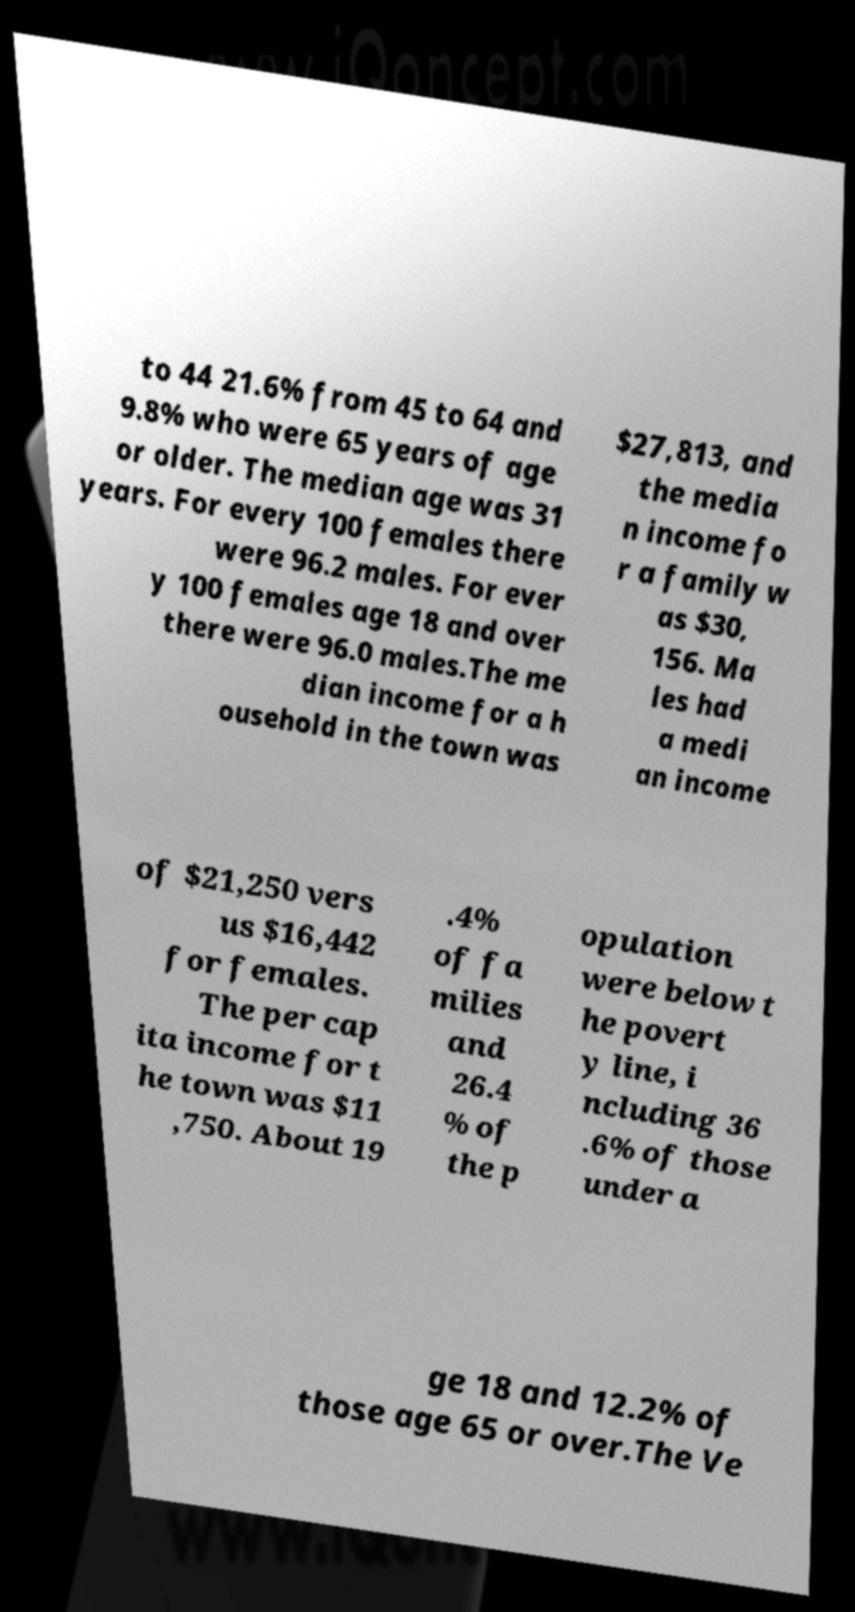Can you read and provide the text displayed in the image?This photo seems to have some interesting text. Can you extract and type it out for me? to 44 21.6% from 45 to 64 and 9.8% who were 65 years of age or older. The median age was 31 years. For every 100 females there were 96.2 males. For ever y 100 females age 18 and over there were 96.0 males.The me dian income for a h ousehold in the town was $27,813, and the media n income fo r a family w as $30, 156. Ma les had a medi an income of $21,250 vers us $16,442 for females. The per cap ita income for t he town was $11 ,750. About 19 .4% of fa milies and 26.4 % of the p opulation were below t he povert y line, i ncluding 36 .6% of those under a ge 18 and 12.2% of those age 65 or over.The Ve 